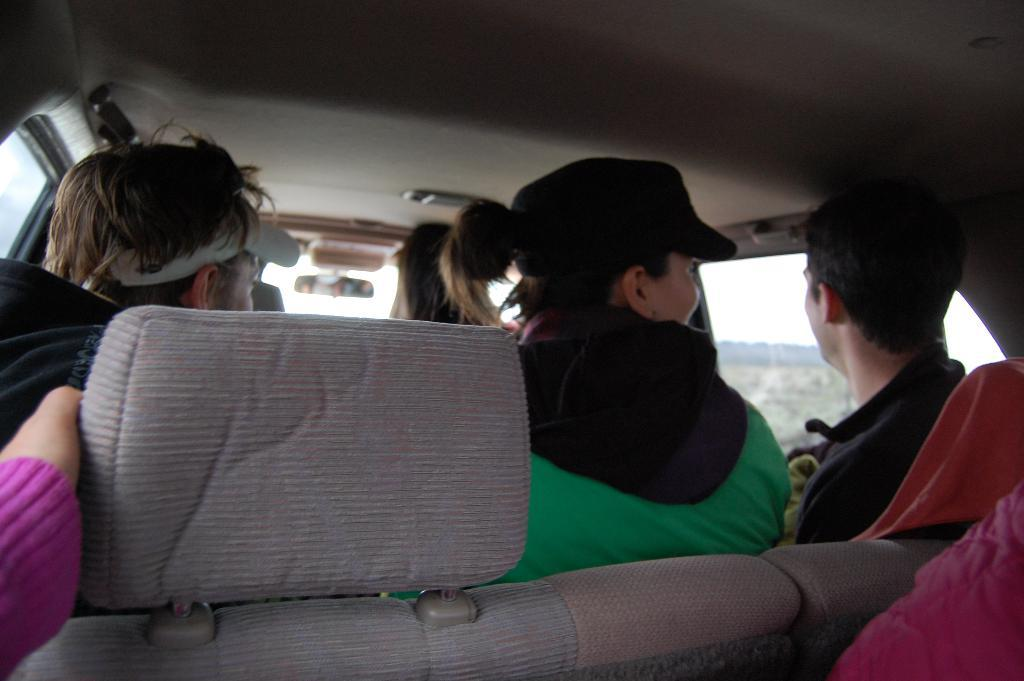What are the people in the image doing? The people in the image are sitting inside the vehicle. What type of window is present in the vehicle? There is a glass window in the vehicle. What can be seen through the glass window in the image? The sky is visible through the glass window. What flavor of pies can be seen in the shop through the glass window? There is no shop or pies present in the image; it only features a vehicle with people inside and a glass window. 